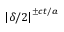<formula> <loc_0><loc_0><loc_500><loc_500>\left | \delta / 2 \right | ^ { \pm c t / a }</formula> 